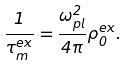<formula> <loc_0><loc_0><loc_500><loc_500>\frac { 1 } { \tau _ { m } ^ { e x } } = \frac { \omega _ { p l } ^ { 2 } } { 4 \pi } \rho _ { 0 } ^ { e x } .</formula> 